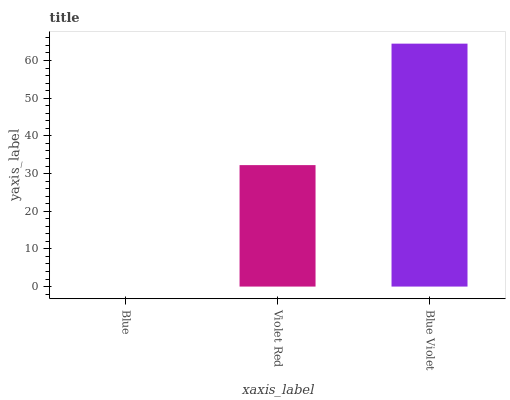Is Violet Red the minimum?
Answer yes or no. No. Is Violet Red the maximum?
Answer yes or no. No. Is Violet Red greater than Blue?
Answer yes or no. Yes. Is Blue less than Violet Red?
Answer yes or no. Yes. Is Blue greater than Violet Red?
Answer yes or no. No. Is Violet Red less than Blue?
Answer yes or no. No. Is Violet Red the high median?
Answer yes or no. Yes. Is Violet Red the low median?
Answer yes or no. Yes. Is Blue Violet the high median?
Answer yes or no. No. Is Blue the low median?
Answer yes or no. No. 